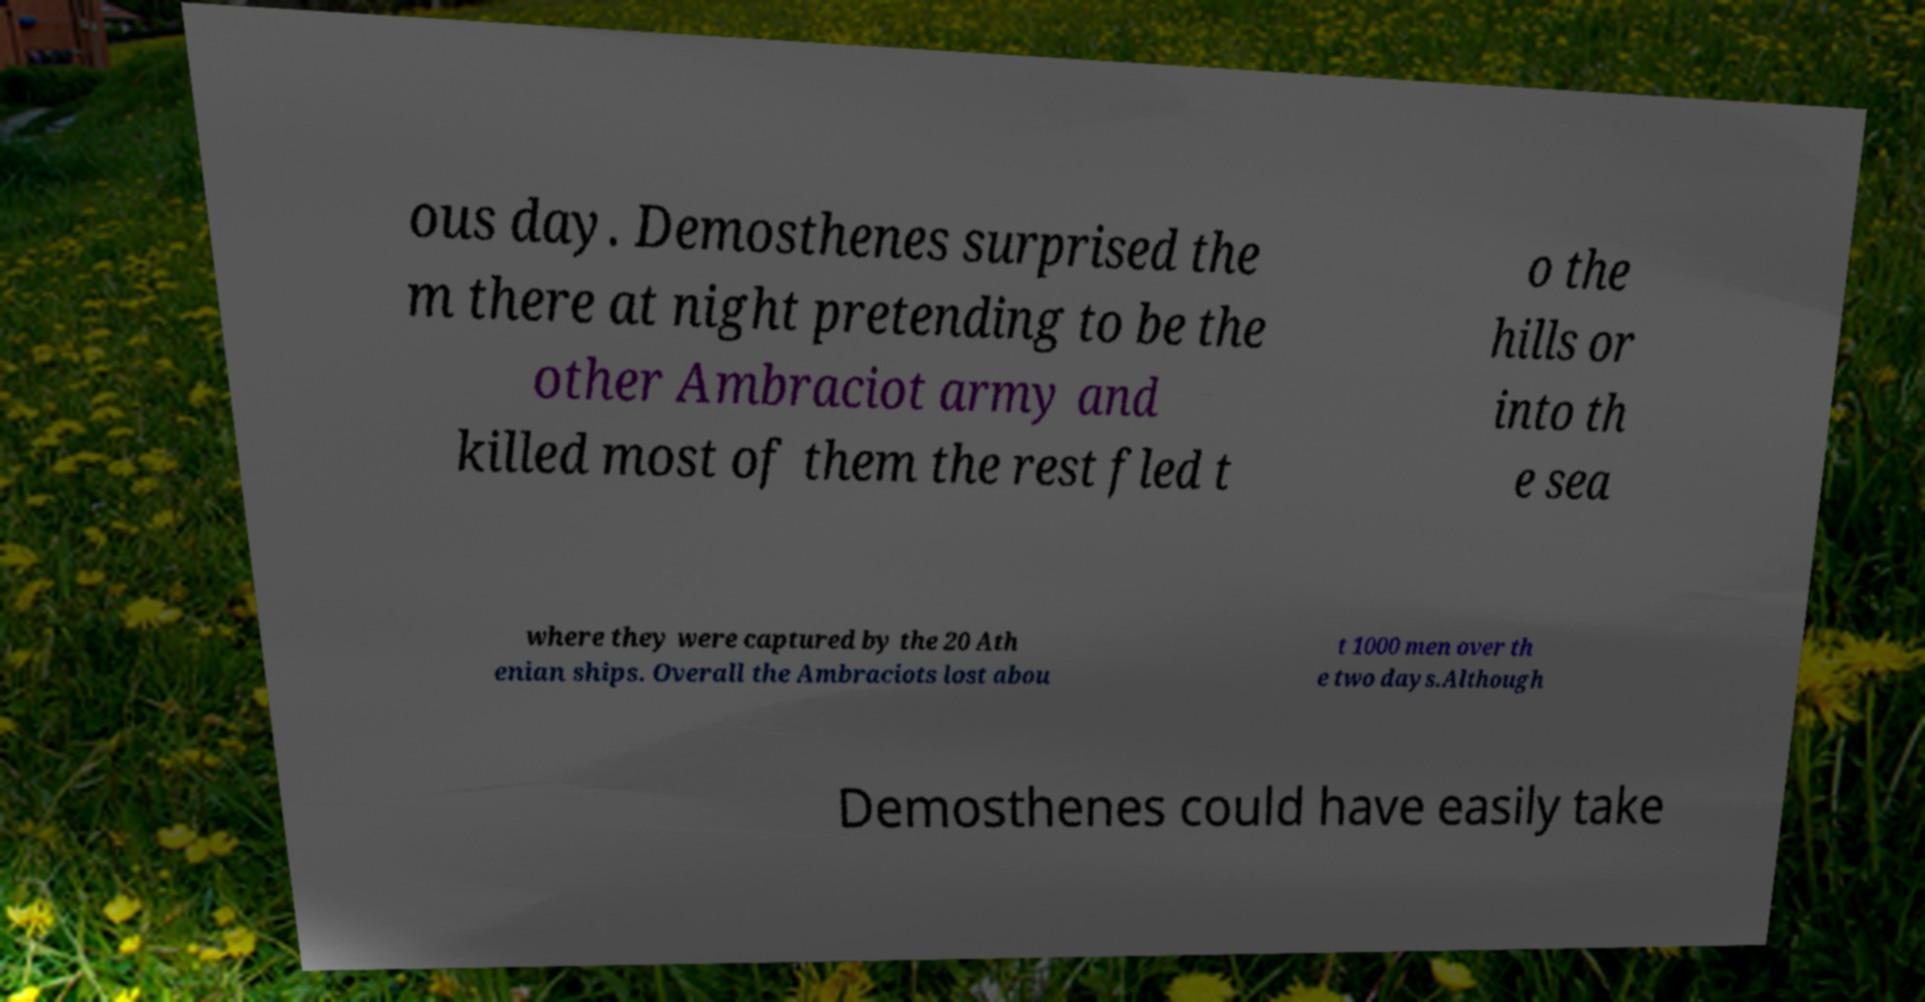Could you extract and type out the text from this image? ous day. Demosthenes surprised the m there at night pretending to be the other Ambraciot army and killed most of them the rest fled t o the hills or into th e sea where they were captured by the 20 Ath enian ships. Overall the Ambraciots lost abou t 1000 men over th e two days.Although Demosthenes could have easily take 